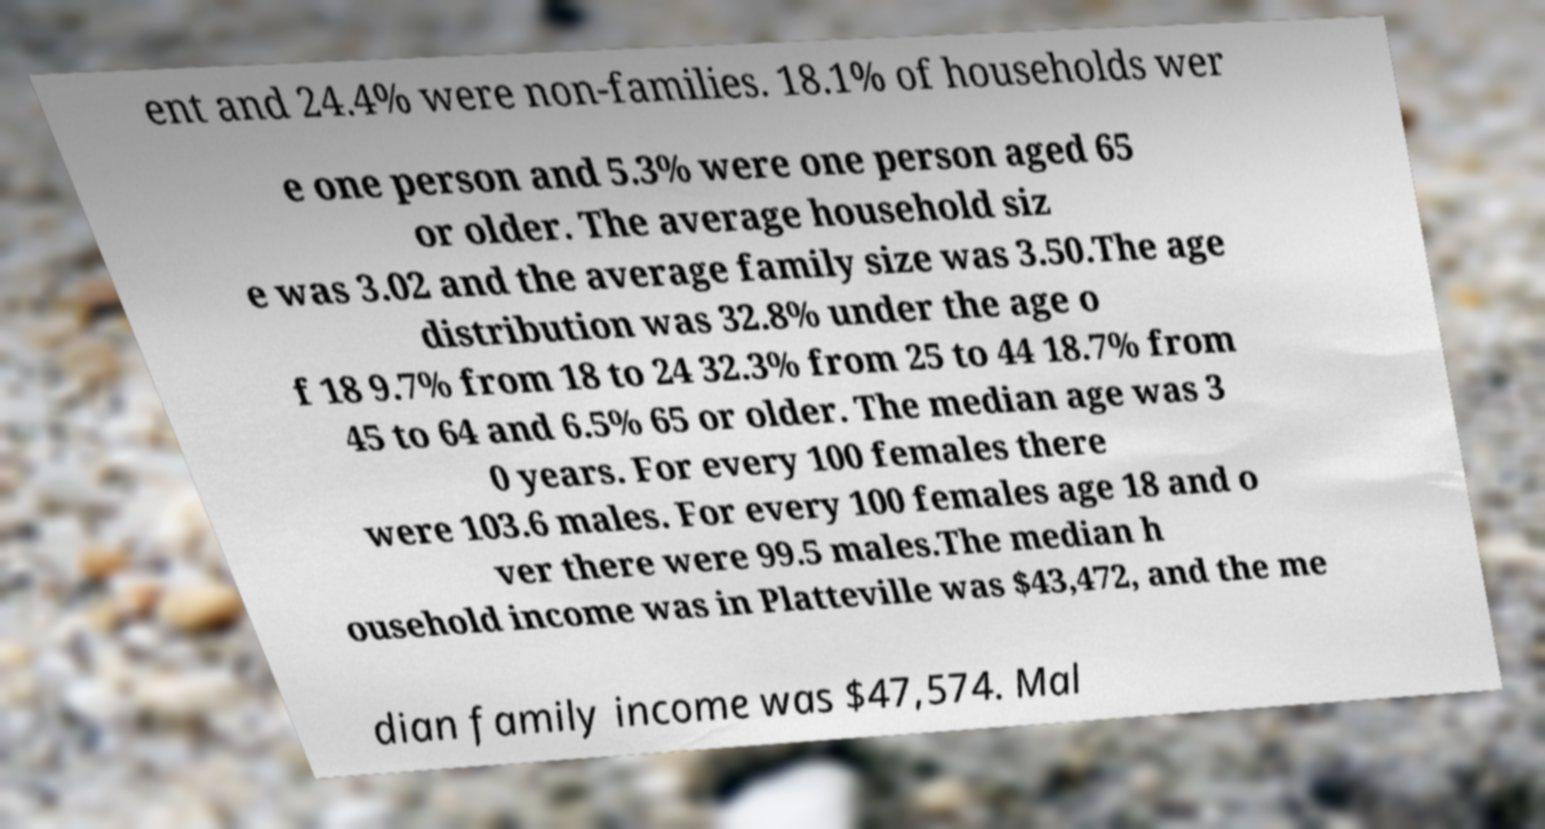Please identify and transcribe the text found in this image. ent and 24.4% were non-families. 18.1% of households wer e one person and 5.3% were one person aged 65 or older. The average household siz e was 3.02 and the average family size was 3.50.The age distribution was 32.8% under the age o f 18 9.7% from 18 to 24 32.3% from 25 to 44 18.7% from 45 to 64 and 6.5% 65 or older. The median age was 3 0 years. For every 100 females there were 103.6 males. For every 100 females age 18 and o ver there were 99.5 males.The median h ousehold income was in Platteville was $43,472, and the me dian family income was $47,574. Mal 